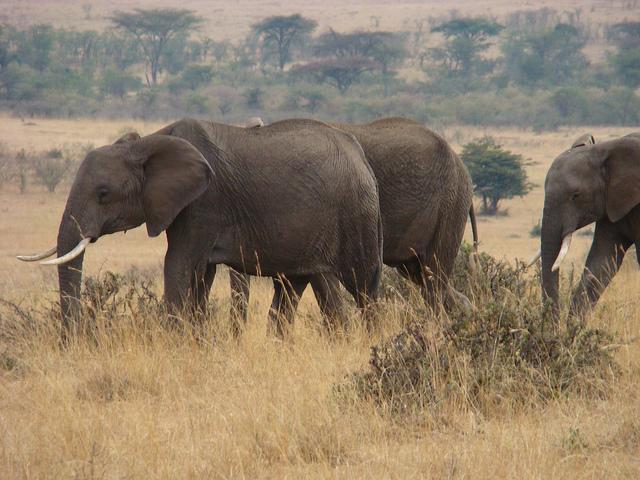How many animals are shown here?
Give a very brief answer. 3. How many elephants can be seen?
Give a very brief answer. 3. How many people are eating?
Give a very brief answer. 0. 